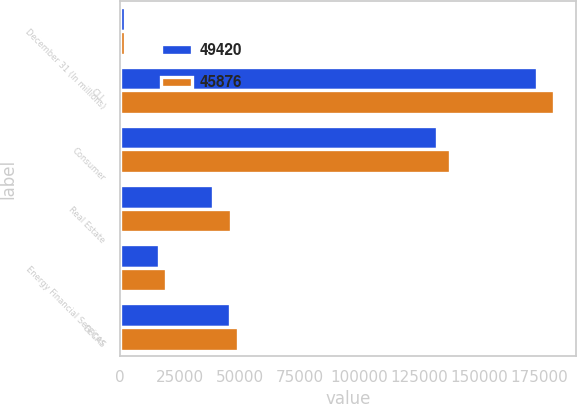Convert chart. <chart><loc_0><loc_0><loc_500><loc_500><stacked_bar_chart><ecel><fcel>December 31 (In millions)<fcel>CLL<fcel>Consumer<fcel>Real Estate<fcel>Energy Financial Services<fcel>GECAS<nl><fcel>49420<fcel>2013<fcel>174357<fcel>132236<fcel>38744<fcel>16203<fcel>45876<nl><fcel>45876<fcel>2012<fcel>181375<fcel>138002<fcel>46247<fcel>19185<fcel>49420<nl></chart> 